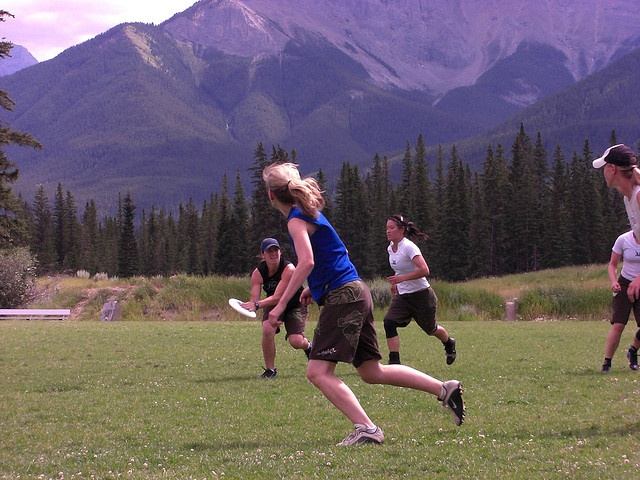Describe the objects in this image and their specific colors. I can see people in white, black, brown, and maroon tones, people in white, black, brown, gray, and maroon tones, people in white, black, brown, and maroon tones, people in white, black, brown, maroon, and violet tones, and people in white, black, maroon, and brown tones in this image. 